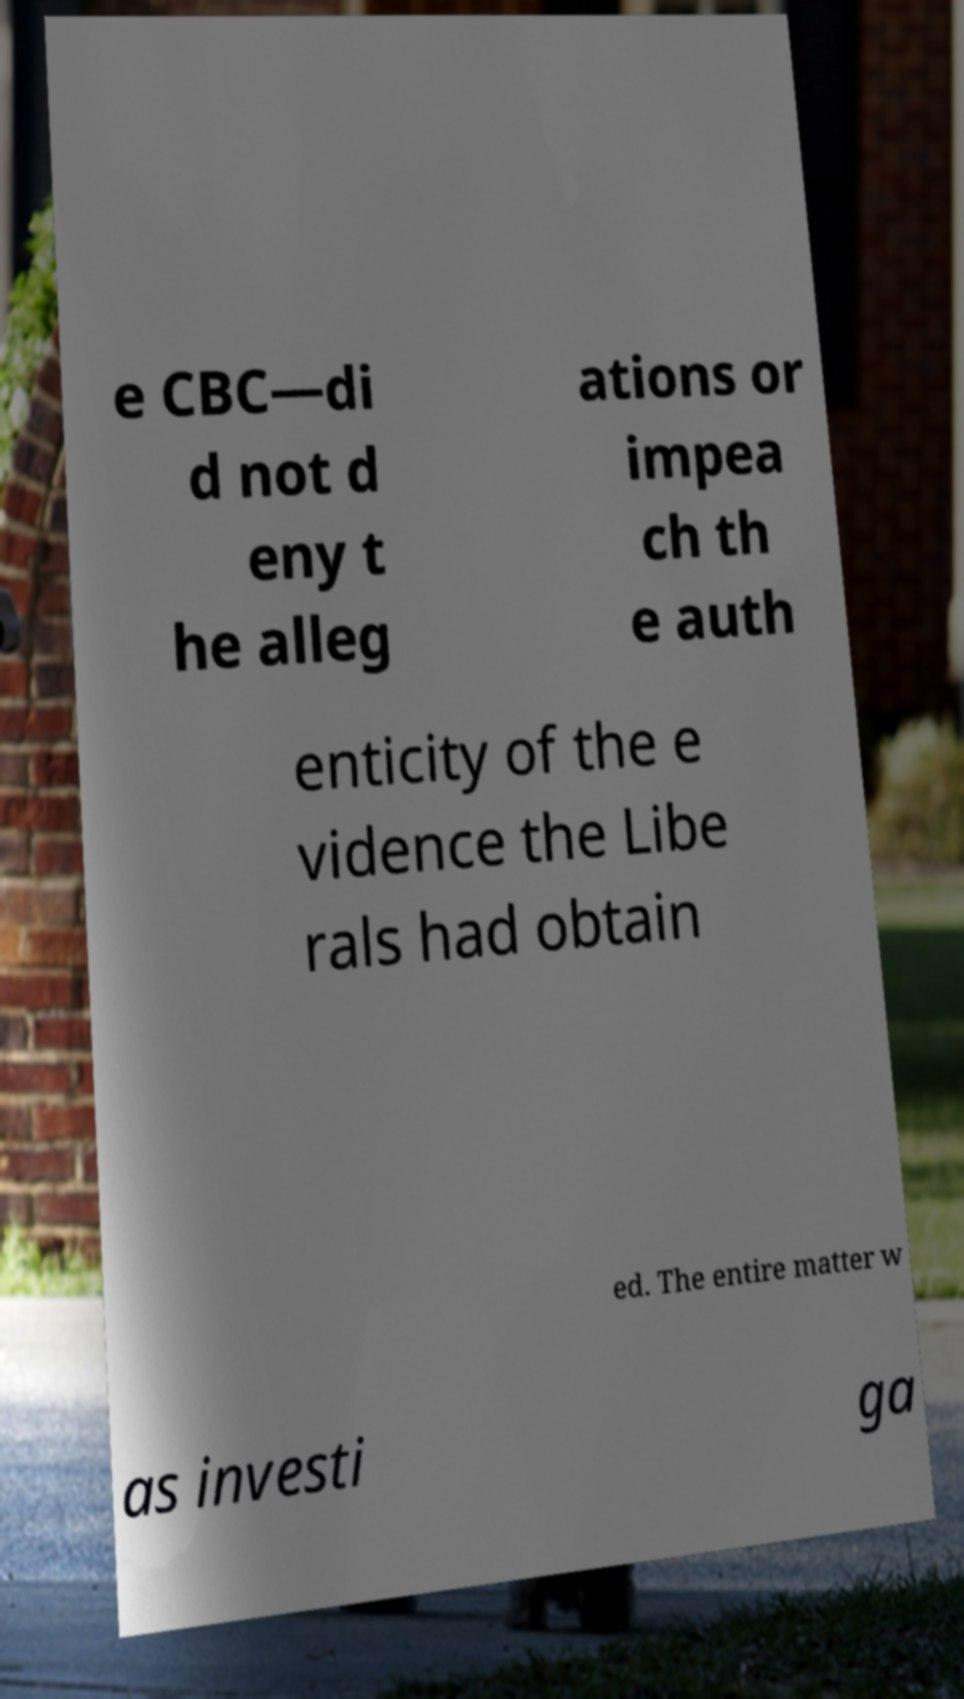Please identify and transcribe the text found in this image. e CBC—di d not d eny t he alleg ations or impea ch th e auth enticity of the e vidence the Libe rals had obtain ed. The entire matter w as investi ga 